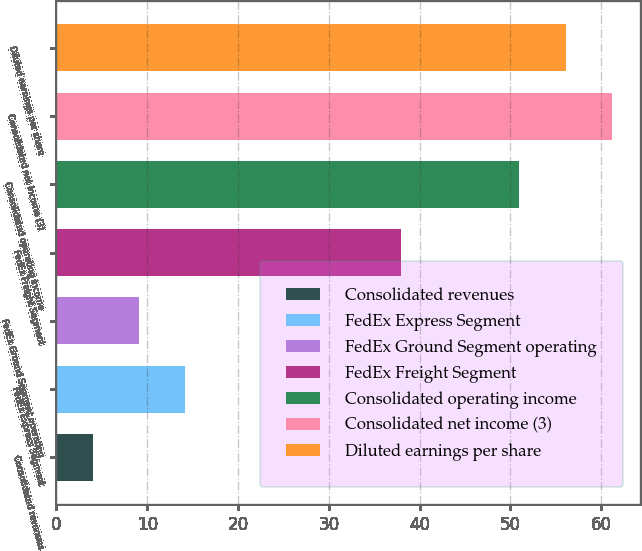<chart> <loc_0><loc_0><loc_500><loc_500><bar_chart><fcel>Consolidated revenues<fcel>FedEx Express Segment<fcel>FedEx Ground Segment operating<fcel>FedEx Freight Segment<fcel>Consolidated operating income<fcel>Consolidated net income (3)<fcel>Diluted earnings per share<nl><fcel>4<fcel>14.2<fcel>9.1<fcel>38<fcel>51<fcel>61.2<fcel>56.1<nl></chart> 